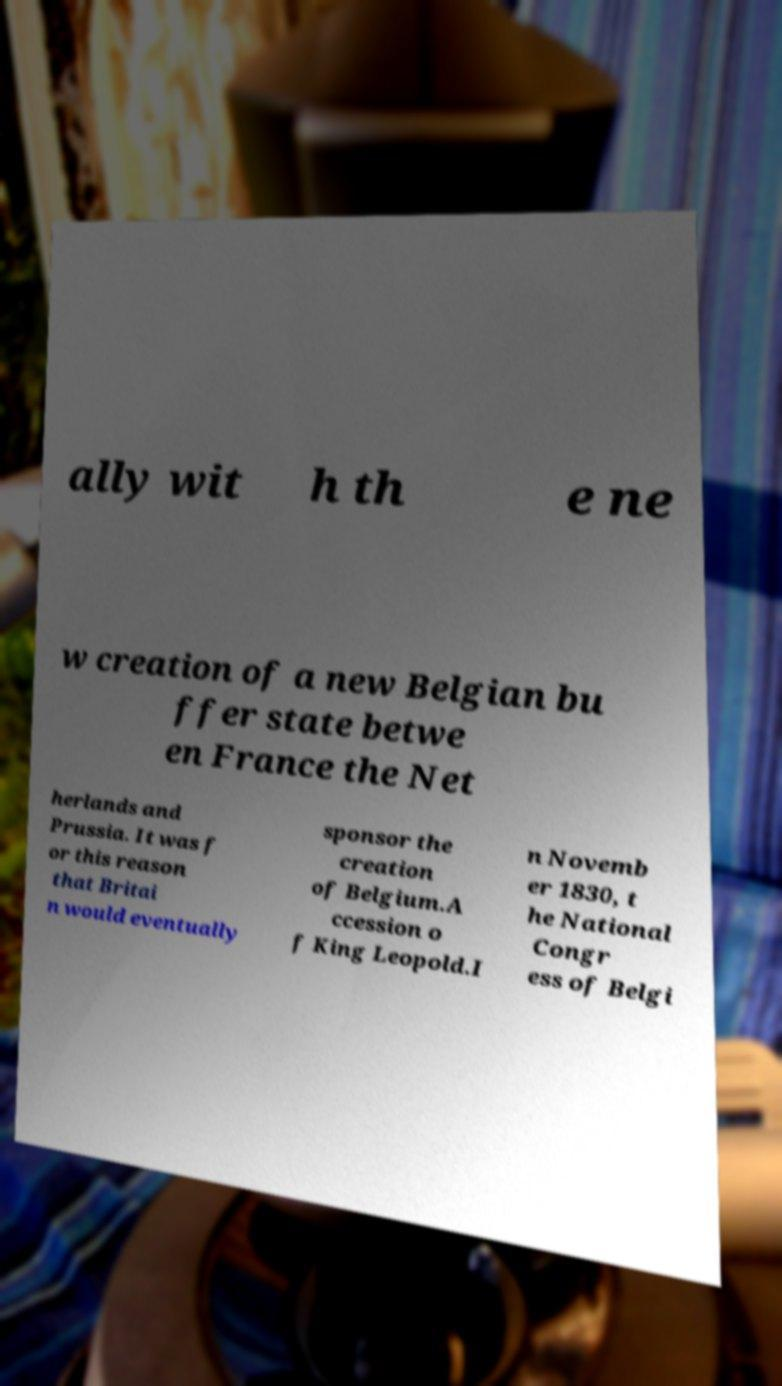Can you accurately transcribe the text from the provided image for me? ally wit h th e ne w creation of a new Belgian bu ffer state betwe en France the Net herlands and Prussia. It was f or this reason that Britai n would eventually sponsor the creation of Belgium.A ccession o f King Leopold.I n Novemb er 1830, t he National Congr ess of Belgi 